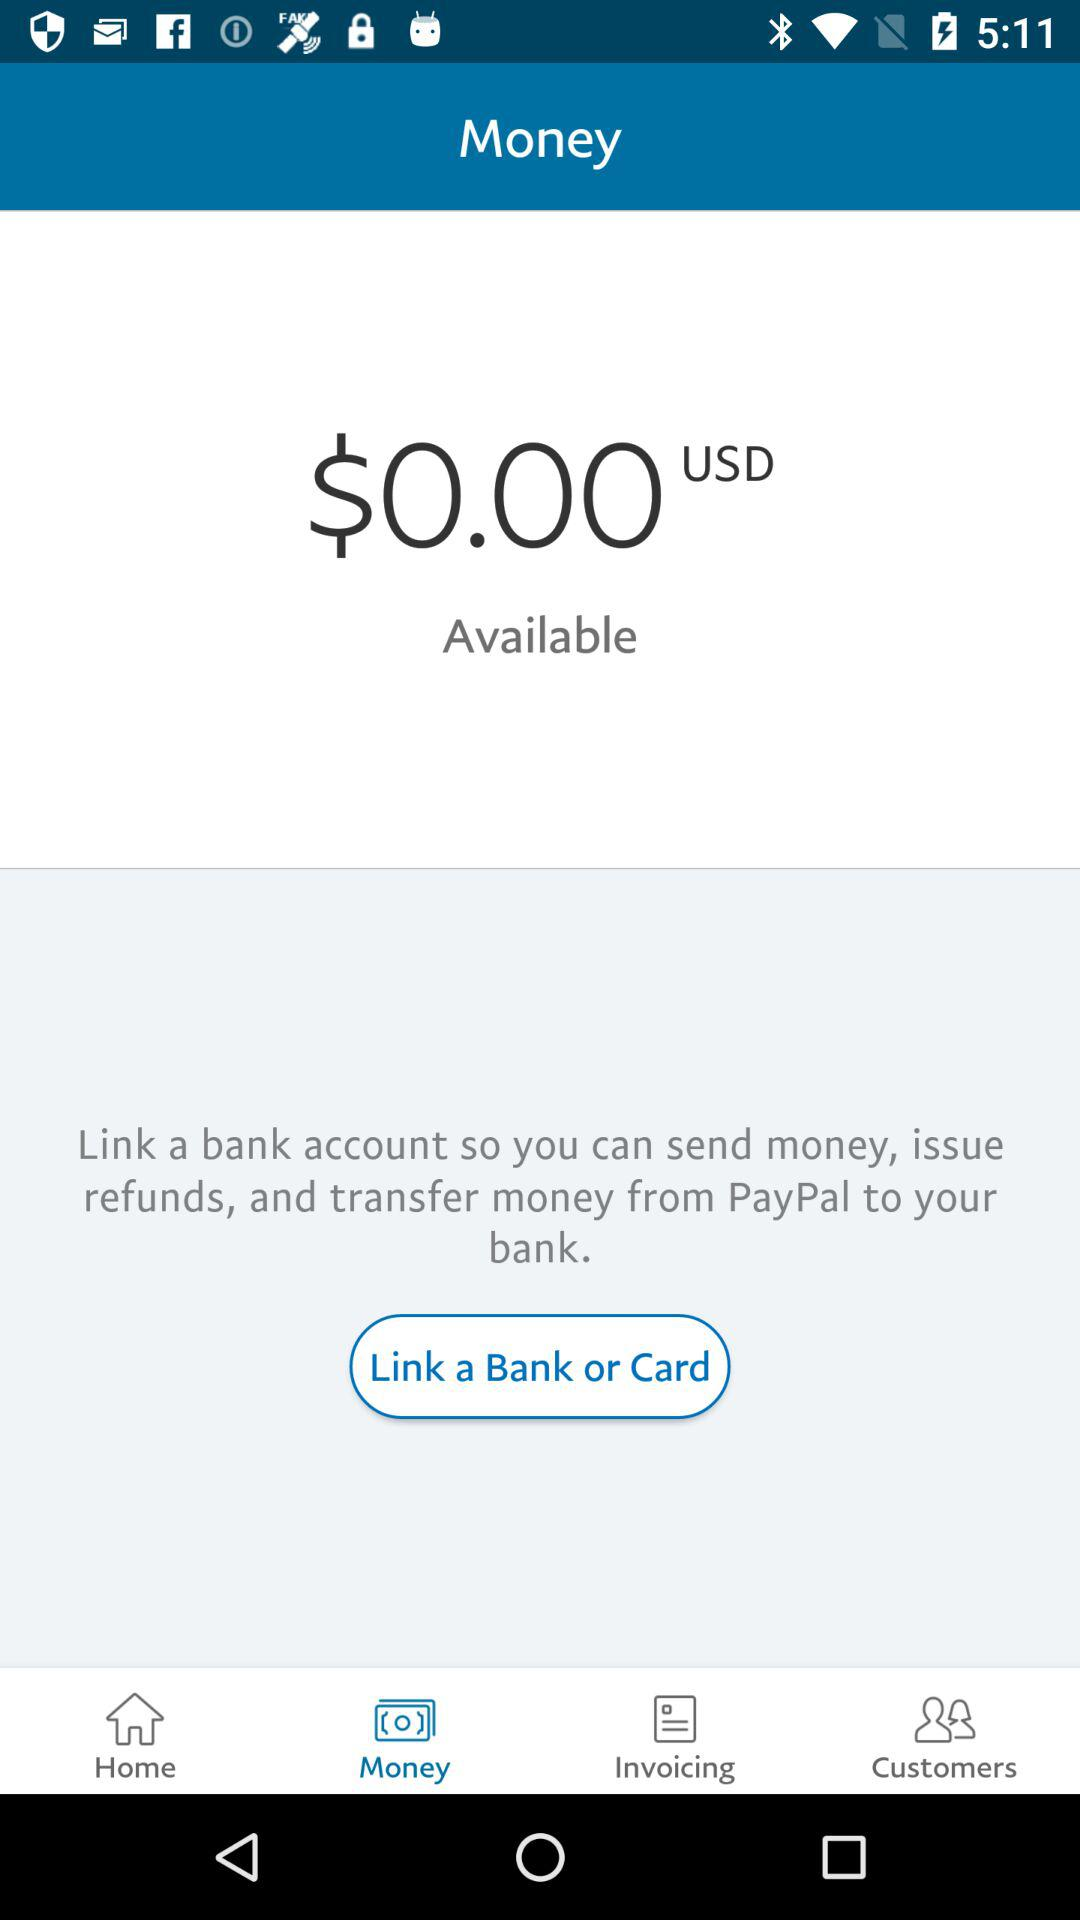Why do we need to link a bank account? We need to link a bank account to send money, issue refunds and transfer money. 